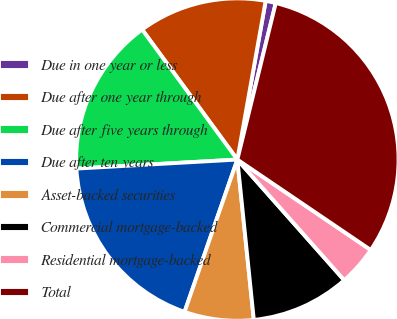<chart> <loc_0><loc_0><loc_500><loc_500><pie_chart><fcel>Due in one year or less<fcel>Due after one year through<fcel>Due after five years through<fcel>Due after ten years<fcel>Asset-backed securities<fcel>Commercial mortgage-backed<fcel>Residential mortgage-backed<fcel>Total<nl><fcel>1.02%<fcel>12.87%<fcel>15.83%<fcel>18.8%<fcel>6.94%<fcel>9.91%<fcel>3.98%<fcel>30.65%<nl></chart> 